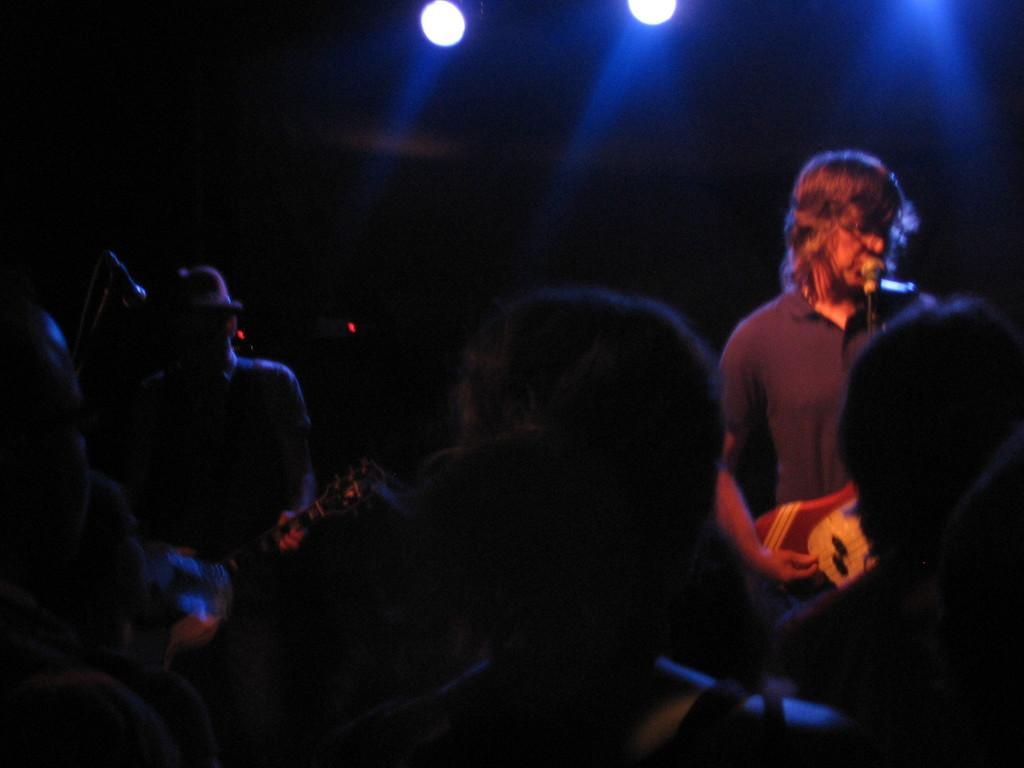What is happening in the image involving the group of people? Two men are playing guitars and singing on microphones. How are the men playing the guitars? The men are playing the guitars with their hands. What can be seen in the background of the image? There are lights visible in the background. Can you describe the lighting conditions in the image? The image appears to be set in a dark environment. What type of building can be seen in the background of the image? There is no building visible in the background of the image; only lights are present. Can you tell me how many volcanoes are erupting in the image? There are no volcanoes present in the image. 